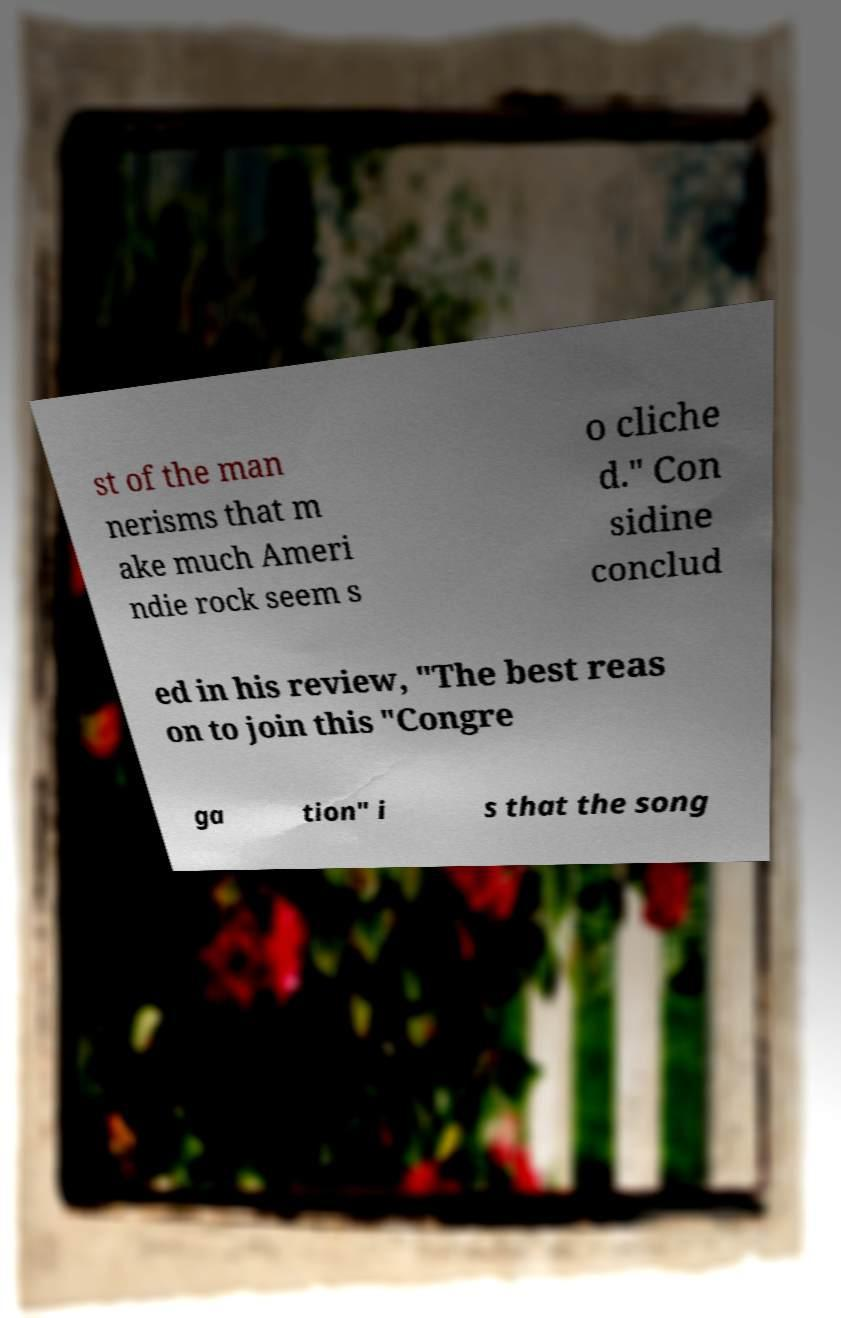Please identify and transcribe the text found in this image. st of the man nerisms that m ake much Ameri ndie rock seem s o cliche d." Con sidine conclud ed in his review, "The best reas on to join this "Congre ga tion" i s that the song 